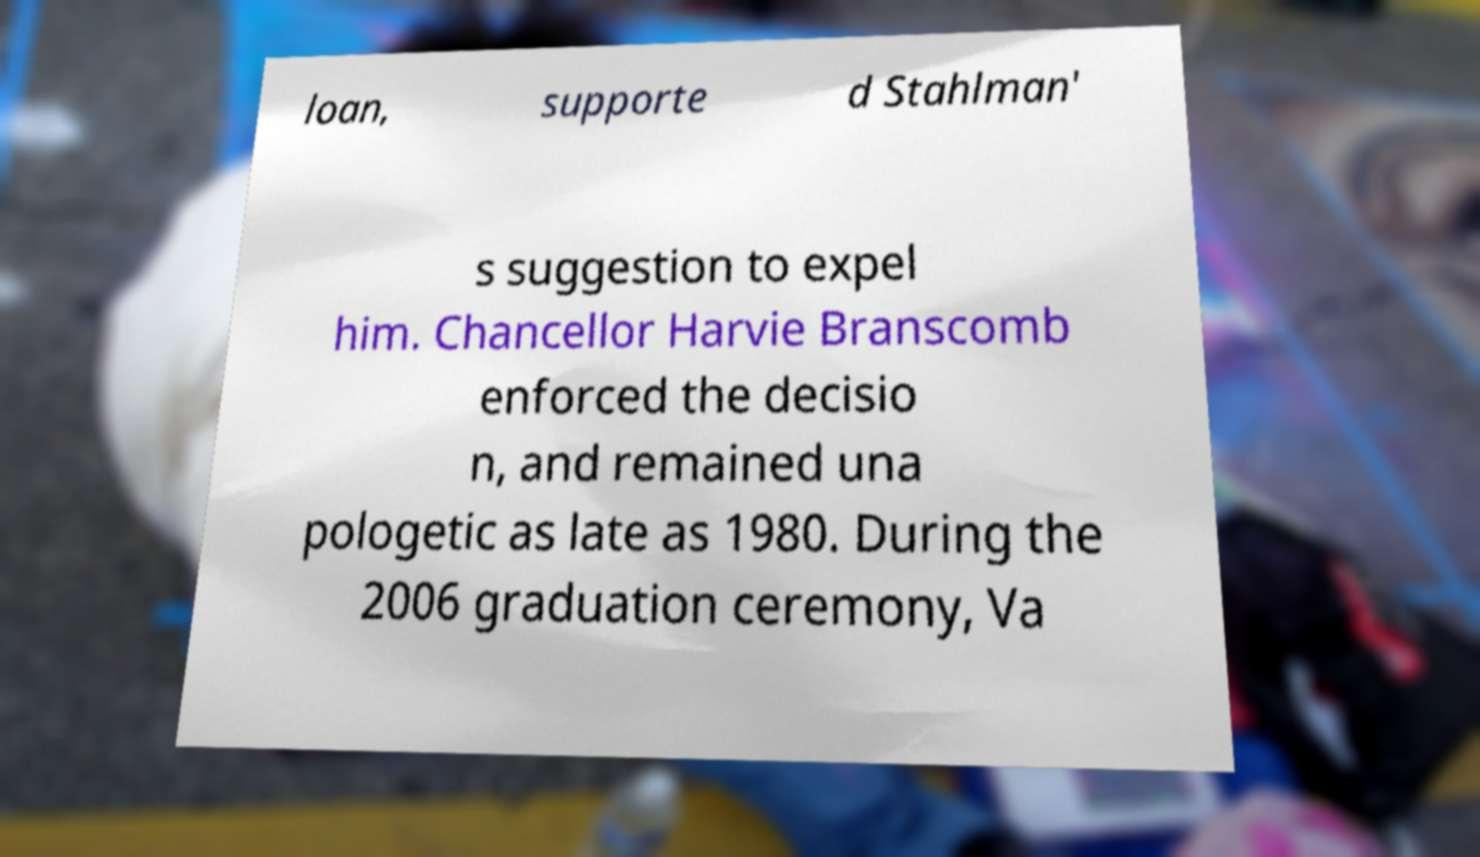Could you extract and type out the text from this image? loan, supporte d Stahlman' s suggestion to expel him. Chancellor Harvie Branscomb enforced the decisio n, and remained una pologetic as late as 1980. During the 2006 graduation ceremony, Va 